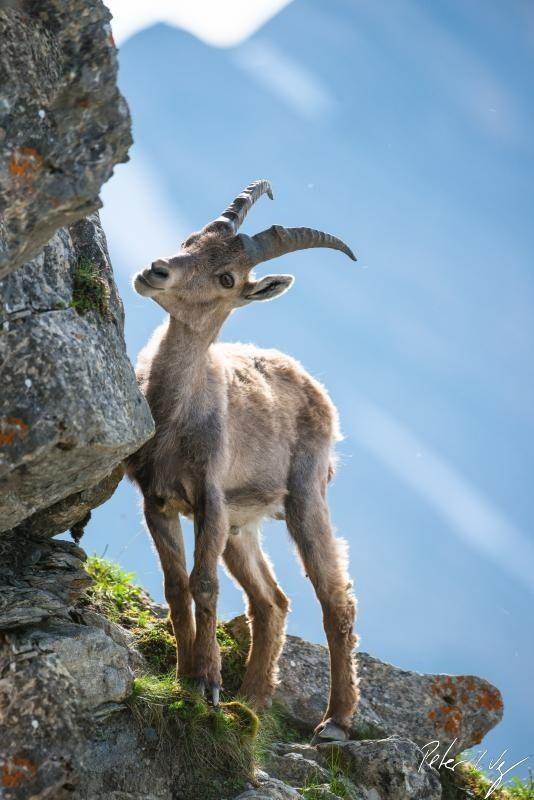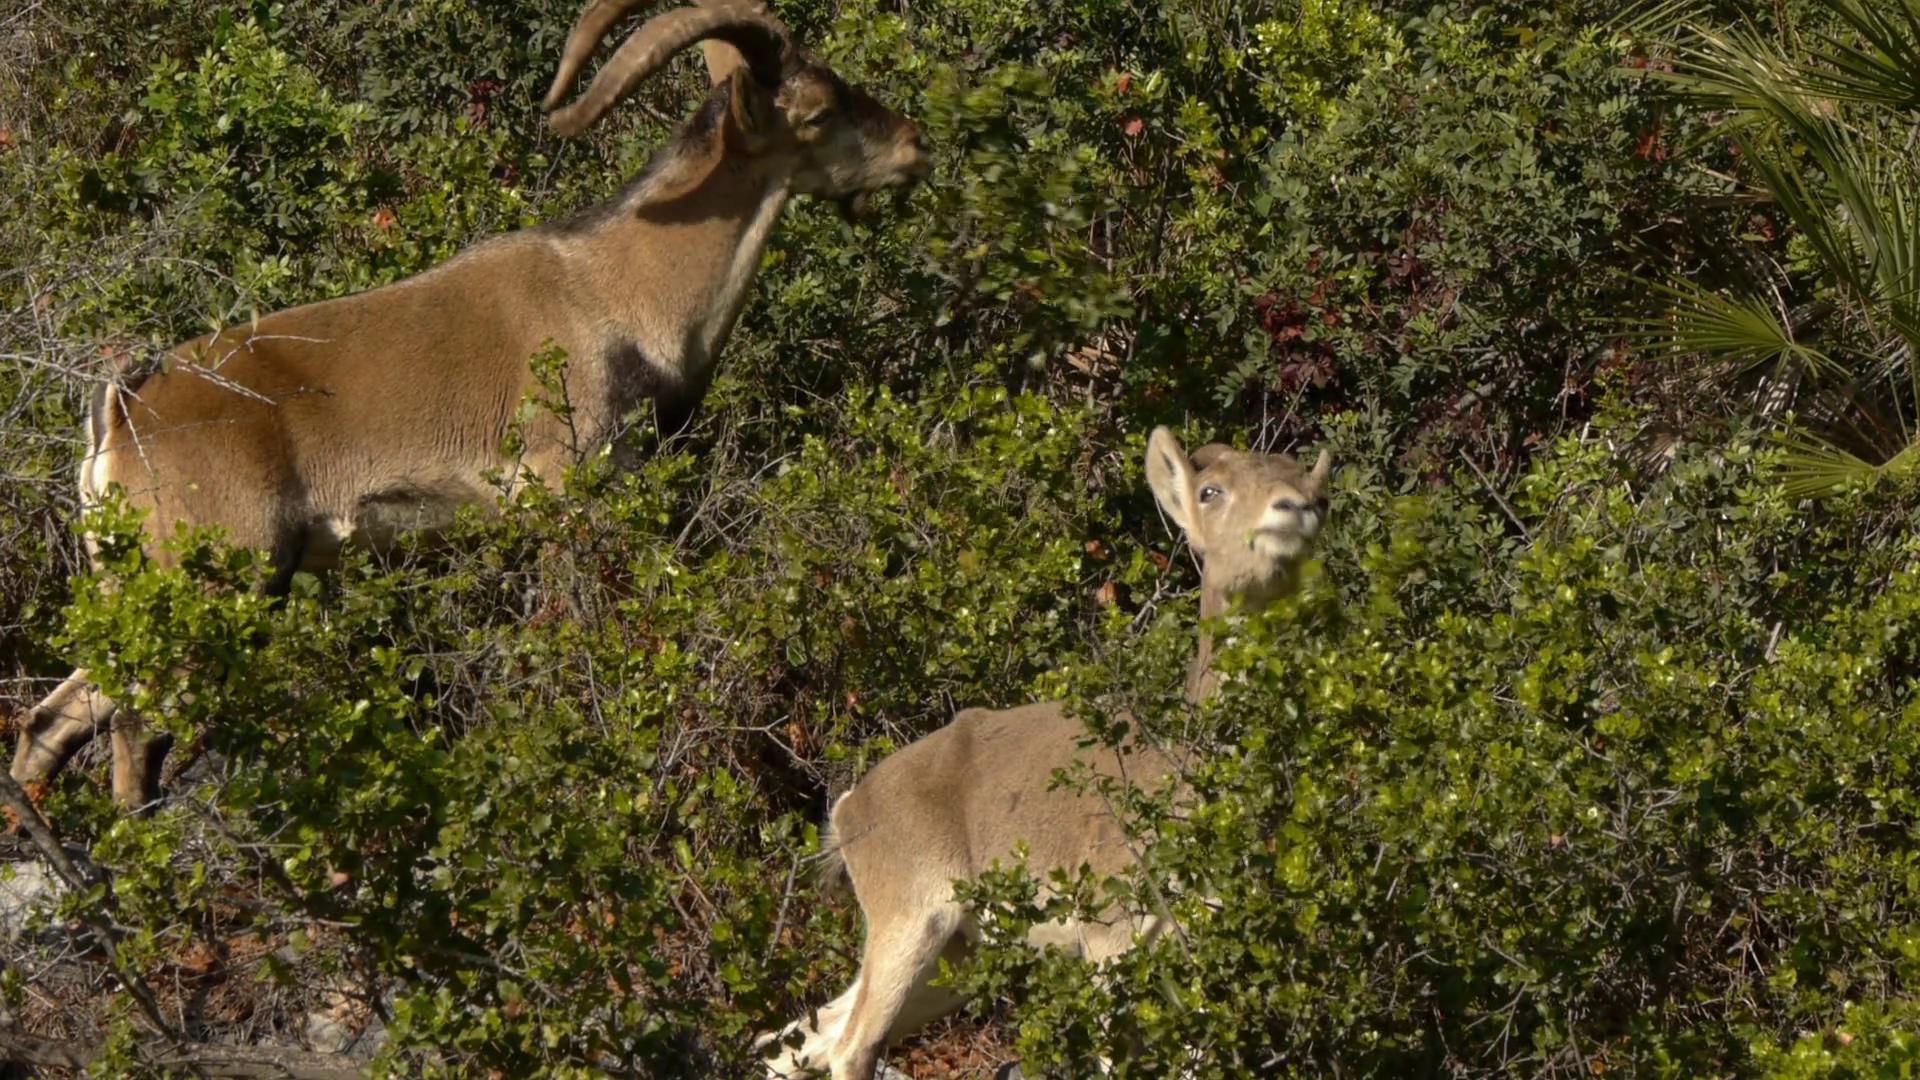The first image is the image on the left, the second image is the image on the right. Assess this claim about the two images: "exactly one goat is in the image to the right, eating grass.". Correct or not? Answer yes or no. No. The first image is the image on the left, the second image is the image on the right. For the images shown, is this caption "An image contains at least two hooved animals in an area with green foliage, with at least one animal upright on all fours." true? Answer yes or no. Yes. 